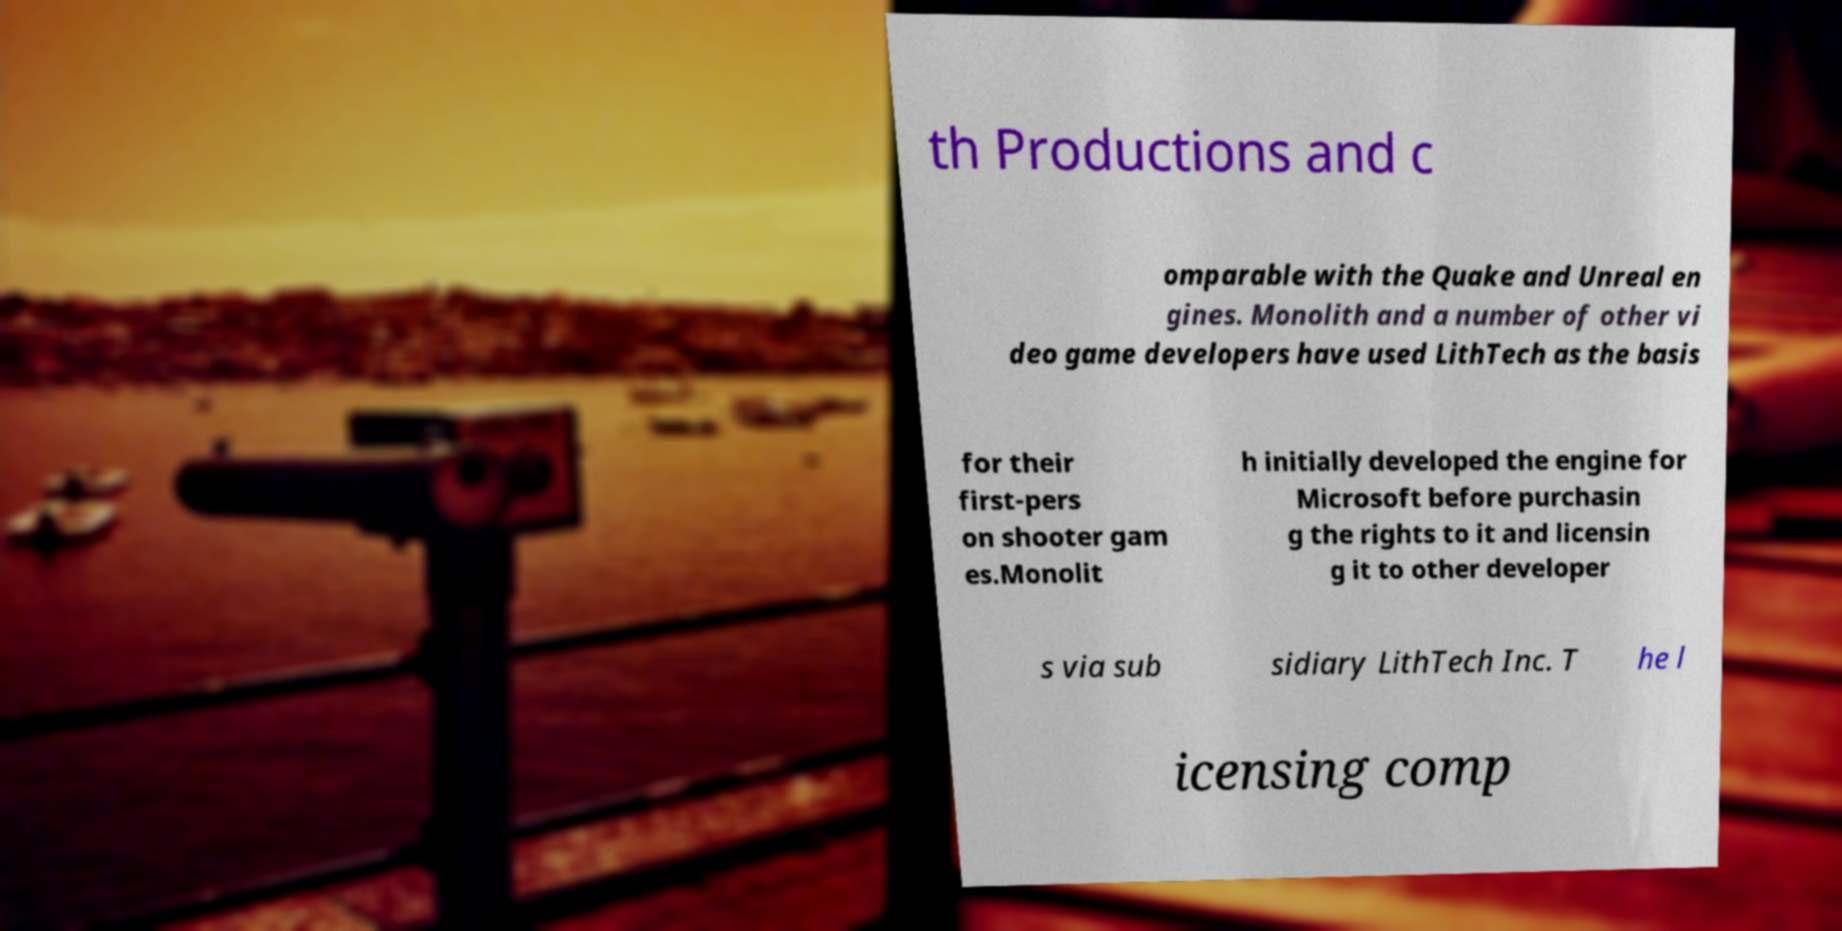Can you read and provide the text displayed in the image?This photo seems to have some interesting text. Can you extract and type it out for me? th Productions and c omparable with the Quake and Unreal en gines. Monolith and a number of other vi deo game developers have used LithTech as the basis for their first-pers on shooter gam es.Monolit h initially developed the engine for Microsoft before purchasin g the rights to it and licensin g it to other developer s via sub sidiary LithTech Inc. T he l icensing comp 